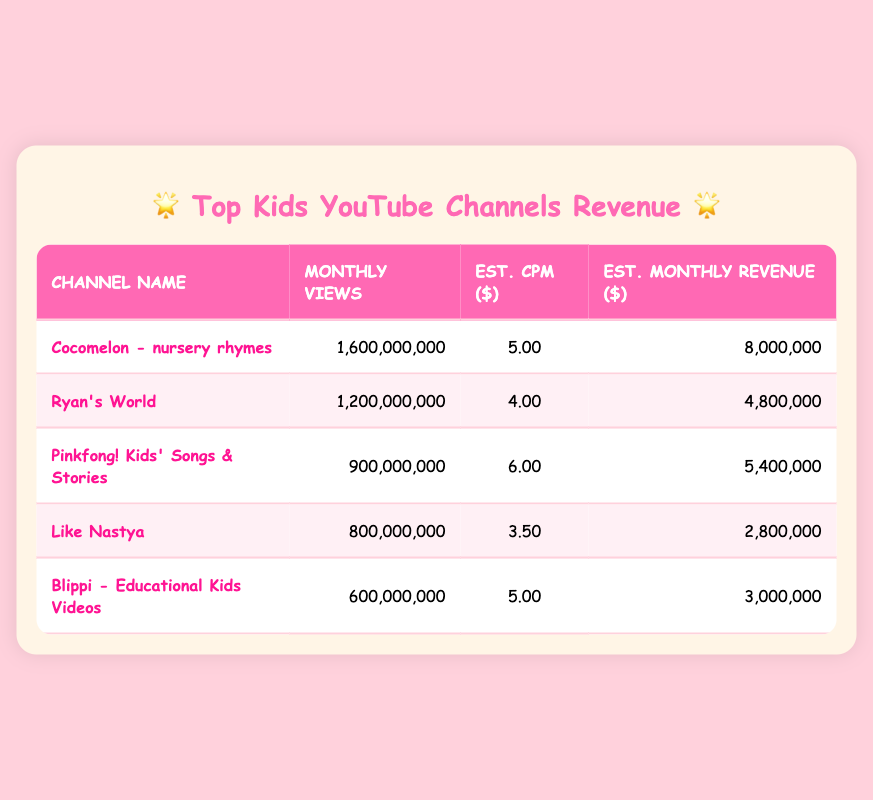What is the estimated monthly revenue for Cocomelon? The table lists Cocomelon's estimated monthly revenue in the designated column. It shows 8,000,000.
Answer: 8,000,000 Which channel has the highest monthly views? By examining the monthly views in the table, Cocomelon has 1,600,000,000 views, the highest of all the listed channels.
Answer: Cocomelon - nursery rhymes What is the average estimated CPM for all the channels? First, we sum the estimated CPM values: 5 + 4 + 6 + 3.5 + 5 = 23.5. There are 5 channels, so the average CPM is 23.5 / 5 = 4.7.
Answer: 4.7 Is the estimated monthly revenue for Blippi greater than 4 million? The table shows Blippi's estimated monthly revenue is 3,000,000, which is not greater than 4 million.
Answer: No Which channel has the lowest estimated monthly revenue? The last row shows that Like Nastya has the lowest estimated monthly revenue of 2,800,000, making it the channel with the least revenue.
Answer: Like Nastya 